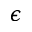Convert formula to latex. <formula><loc_0><loc_0><loc_500><loc_500>\epsilon</formula> 